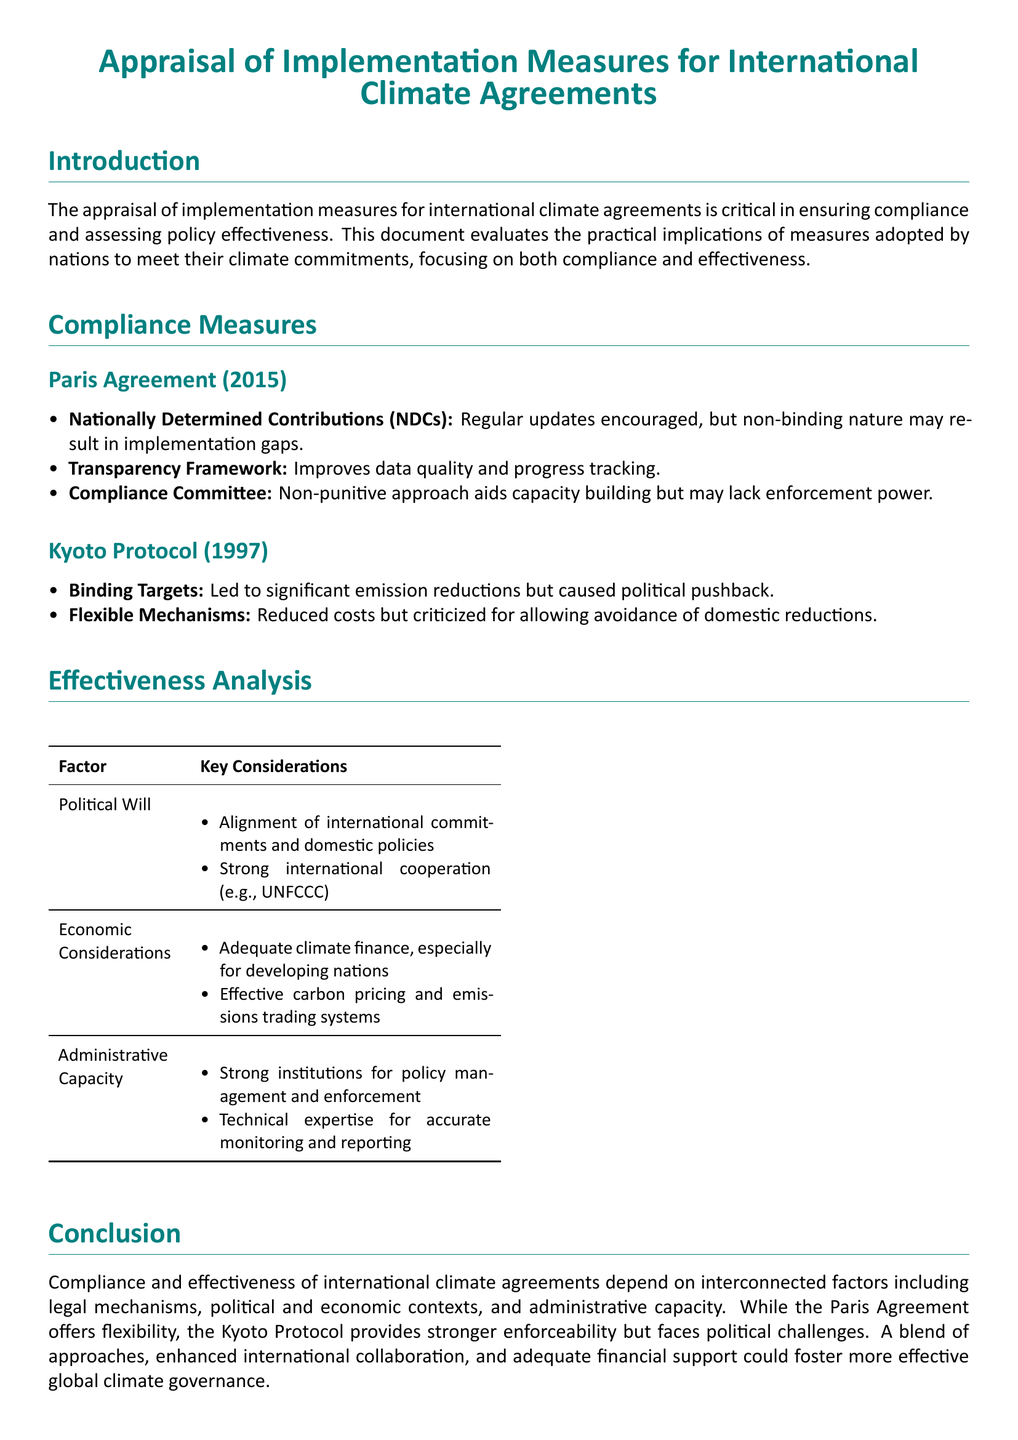what are NDCs? NDCs refer to Nationally Determined Contributions, which are commitments made by countries to reduce greenhouse gas emissions and address climate change under the Paris Agreement.
Answer: Nationally Determined Contributions what is the Transparency Framework? The Transparency Framework is a measure that improves data quality and progress tracking in the context of the Paris Agreement.
Answer: Improves data quality and progress tracking what was a significant feature of the Kyoto Protocol? A significant feature of the Kyoto Protocol was the introduction of Binding Targets that led to significant emission reductions.
Answer: Binding Targets what are two factors that affect the effectiveness of climate agreements? The effectiveness of climate agreements is influenced by Political Will and Economic Considerations, among others.
Answer: Political Will, Economic Considerations how does the Compliance Committee of the Paris Agreement approach compliance? The Compliance Committee employs a non-punitive approach that aids capacity building but may lack enforcement power.
Answer: Non-punitive approach what issue did flexible mechanisms in the Kyoto Protocol face? Flexible mechanisms in the Kyoto Protocol were criticized for allowing avoidance of domestic reductions.
Answer: Avoidance of domestic reductions what does adequate climate finance support? Adequate climate finance supports developing nations, facilitating their ability to meet climate goals.
Answer: Developing nations which agreement provides stronger enforceability? The Kyoto Protocol provides stronger enforceability compared to the Paris Agreement.
Answer: Kyoto Protocol 